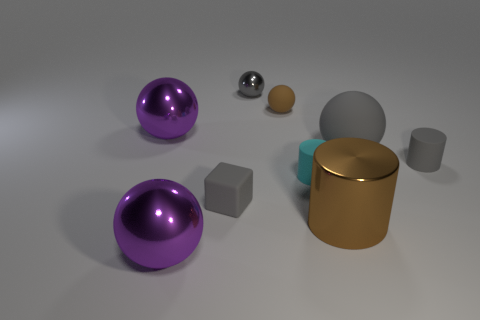Subtract all small metal balls. How many balls are left? 4 Add 1 green matte balls. How many objects exist? 10 Subtract all cyan cylinders. How many cylinders are left? 2 Subtract 1 cylinders. How many cylinders are left? 2 Subtract all balls. How many objects are left? 4 Subtract all cyan balls. How many brown cylinders are left? 1 Subtract all gray cylinders. Subtract all big yellow matte balls. How many objects are left? 8 Add 4 gray matte cylinders. How many gray matte cylinders are left? 5 Add 1 small gray things. How many small gray things exist? 4 Subtract 0 brown blocks. How many objects are left? 9 